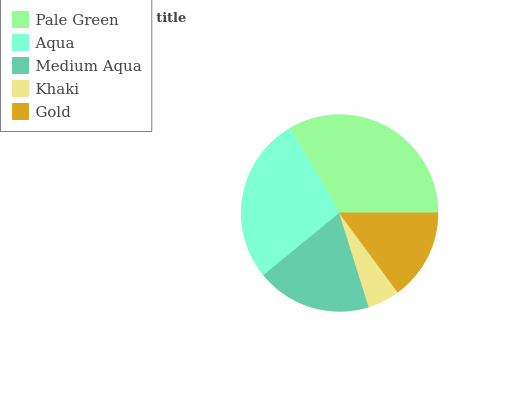Is Khaki the minimum?
Answer yes or no. Yes. Is Pale Green the maximum?
Answer yes or no. Yes. Is Aqua the minimum?
Answer yes or no. No. Is Aqua the maximum?
Answer yes or no. No. Is Pale Green greater than Aqua?
Answer yes or no. Yes. Is Aqua less than Pale Green?
Answer yes or no. Yes. Is Aqua greater than Pale Green?
Answer yes or no. No. Is Pale Green less than Aqua?
Answer yes or no. No. Is Medium Aqua the high median?
Answer yes or no. Yes. Is Medium Aqua the low median?
Answer yes or no. Yes. Is Pale Green the high median?
Answer yes or no. No. Is Aqua the low median?
Answer yes or no. No. 